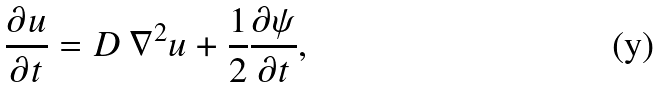Convert formula to latex. <formula><loc_0><loc_0><loc_500><loc_500>\frac { \partial u } { \partial t } = D \, \nabla ^ { 2 } u + \frac { 1 } { 2 } \frac { \partial \psi } { \partial t } ,</formula> 